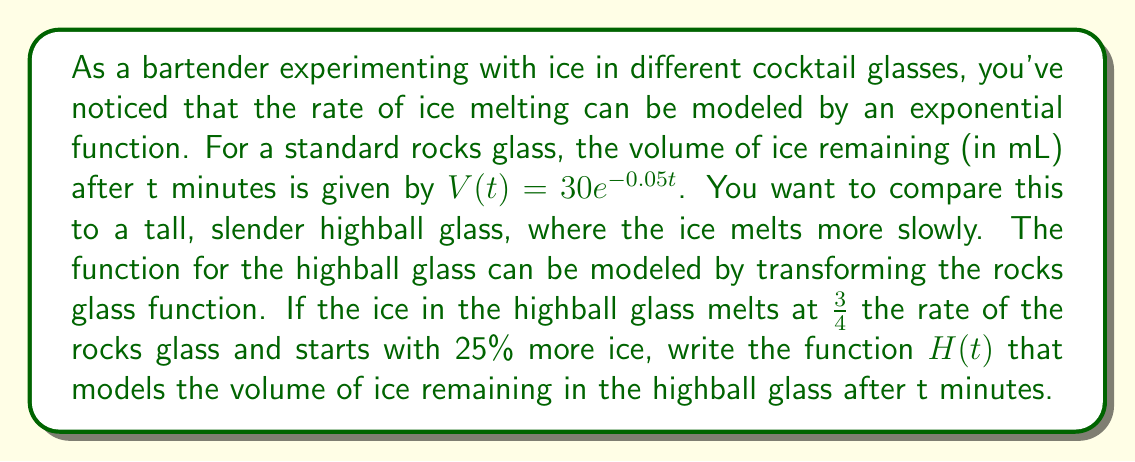Provide a solution to this math problem. Let's approach this step-by-step:

1) The original function for the rocks glass is:
   $V(t) = 30e^{-0.05t}$

2) We need to make two transformations to this function:
   a) Slow down the rate of melting
   b) Increase the initial volume of ice

3) To slow down the rate of melting to 3/4 of the original:
   - Multiply the exponent by 3/4
   $30e^{-0.05(3/4)t} = 30e^{-0.0375t}$

4) To increase the initial volume of ice by 25%:
   - Multiply the coefficient by 1.25
   $1.25 \cdot 30e^{-0.0375t} = 37.5e^{-0.0375t}$

5) Combining these transformations, we get the function for the highball glass:
   $H(t) = 37.5e^{-0.0375t}$

This function represents the volume of ice remaining in the highball glass after t minutes, with a slower melting rate and more initial ice compared to the rocks glass.
Answer: $H(t) = 37.5e^{-0.0375t}$ 